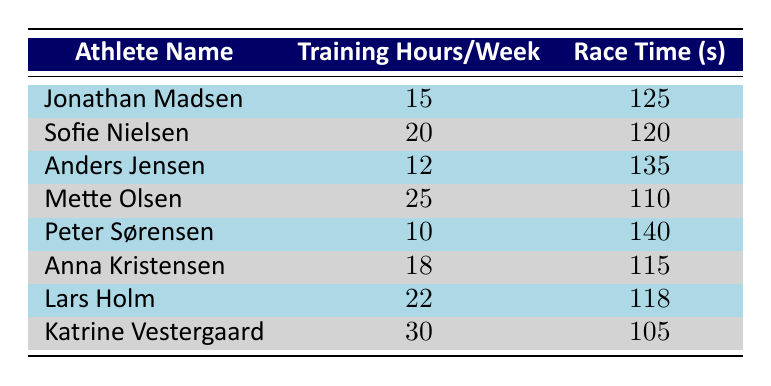What is the training hours per week for Mette Olsen? According to the table, Mette Olsen is listed with 25 training hours per week.
Answer: 25 Which athlete has the fastest race time? By examining the race time column, we see that Katrine Vestergaard has the fastest race time of 105 seconds.
Answer: Katrine Vestergaard What is the race time difference between the athlete with the most training hours and the athlete with the least training hours? The athlete with the most training hours is Katrine Vestergaard (30 hours, 105 seconds) and the one with the least is Peter Sørensen (10 hours, 140 seconds). The difference in race times is 140 - 105 = 35 seconds.
Answer: 35 seconds Is Sofie Nielsen’s training hours higher than Jonathan Madsen’s? Sofie Nielsen's training hours are 20, while Jonathan Madsen’s are 15. Therefore, 20 is greater than 15, making the statement true.
Answer: Yes What is the average race time for all athletes combined? To find the average, we sum all the race times: 125 + 120 + 135 + 110 + 140 + 115 + 118 + 105 = 1,068 seconds. Dividing this sum by 8 (the number of athletes), we get 1,068 / 8 = 133.5 seconds.
Answer: 133.5 seconds Which athlete's training hours are closest to the median training hours in the dataset? The median is found by ordering the training hours: (10, 12, 15, 18, 20, 22, 25, 30) which gives a median of (18 + 20)/2 = 19. The athlete closest to this is Anna Kristensen with 18 hours or Lars Holm with 22 hours.
Answer: Anna Kristensen and Lars Holm How many athletes trained more than 20 hours per week? Looking at the data, we see that Mette Olsen (25 hours), Lars Holm (22 hours), and Katrine Vestergaard (30 hours) are the only athletes with more than 20 training hours. This totals to 3 athletes.
Answer: 3 athletes Is there an athlete with a race time longer than 130 seconds? Checking the race times, we see that both Anders Jensen (135 seconds) and Peter Sørensen (140 seconds) have times greater than 130 seconds, confirming that there are athletes with race times longer than this value.
Answer: Yes 